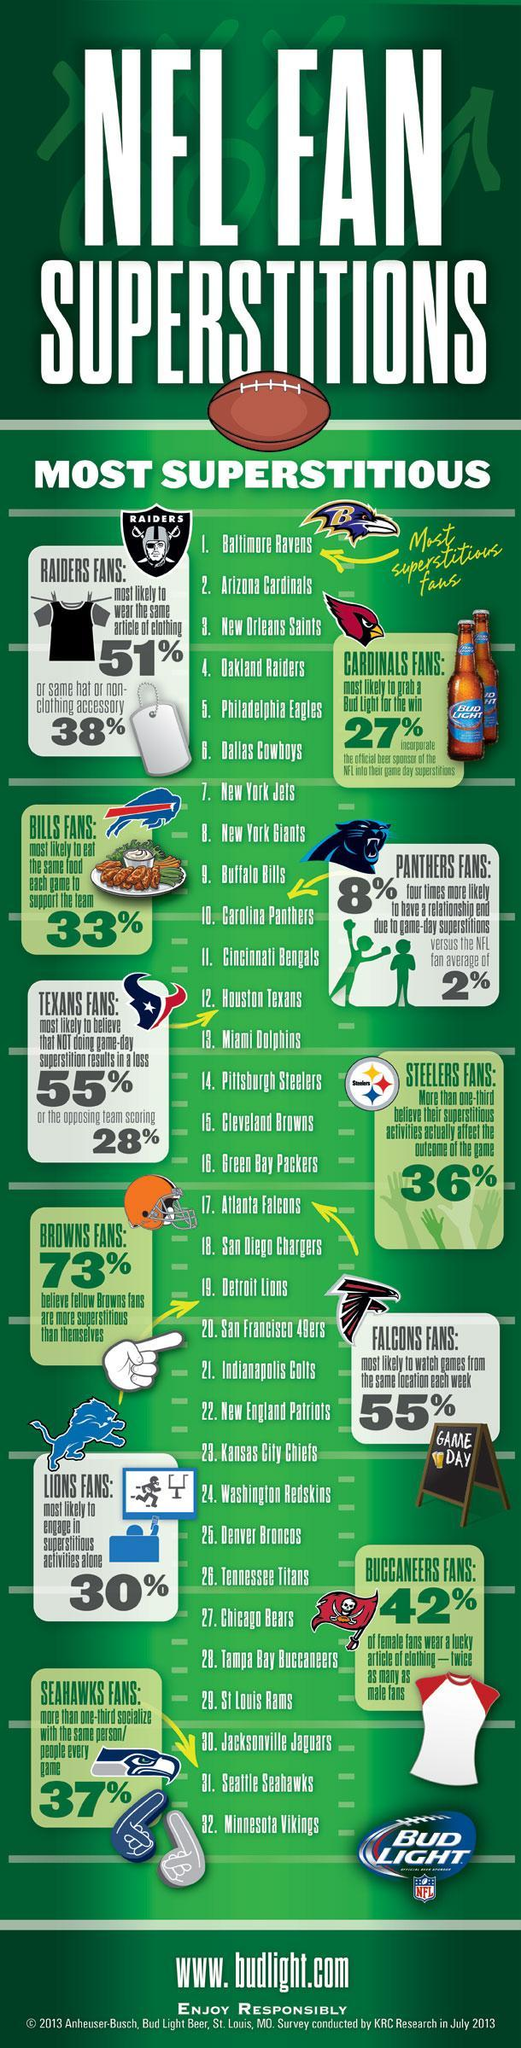Which NFL team fans are the most superstitious?
Answer the question with a short phrase. Baltimore Ravens What percentage of the 'Oakland Raiders' fans are most likely to wear the same article of clothing? 51% Which NFL team fans are the second-most superstitious? Arizona Cardinals What percentage of the 'Buffalo Bills' fans are most likely to eat the same food each game to support the team? 33% What percentage of the 'Detroit Lions' fans are most likely to engage in superstitious activities alone? 30% 